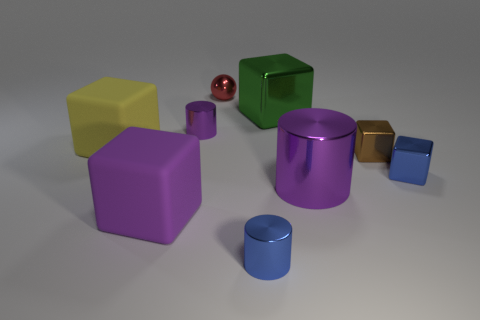Subtract all brown cubes. How many cubes are left? 4 Subtract all green shiny cubes. How many cubes are left? 4 Add 1 brown metallic objects. How many objects exist? 10 Subtract all cyan blocks. Subtract all purple balls. How many blocks are left? 5 Subtract all cylinders. How many objects are left? 6 Subtract all small blue cylinders. Subtract all tiny red balls. How many objects are left? 7 Add 1 brown objects. How many brown objects are left? 2 Add 8 big gray metal cylinders. How many big gray metal cylinders exist? 8 Subtract 1 blue blocks. How many objects are left? 8 